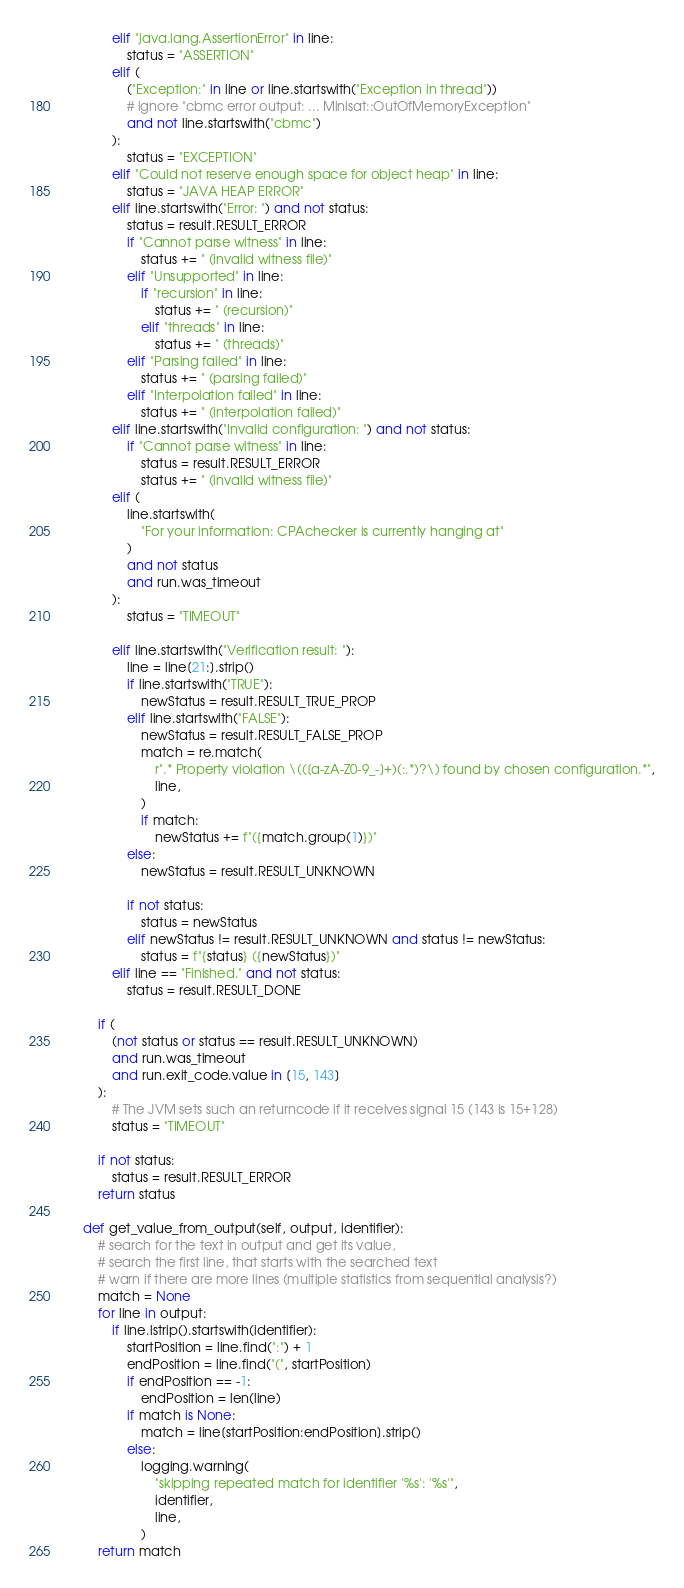<code> <loc_0><loc_0><loc_500><loc_500><_Python_>            elif "java.lang.AssertionError" in line:
                status = "ASSERTION"
            elif (
                ("Exception:" in line or line.startswith("Exception in thread"))
                # ignore "cbmc error output: ... Minisat::OutOfMemoryException"
                and not line.startswith("cbmc")
            ):
                status = "EXCEPTION"
            elif "Could not reserve enough space for object heap" in line:
                status = "JAVA HEAP ERROR"
            elif line.startswith("Error: ") and not status:
                status = result.RESULT_ERROR
                if "Cannot parse witness" in line:
                    status += " (invalid witness file)"
                elif "Unsupported" in line:
                    if "recursion" in line:
                        status += " (recursion)"
                    elif "threads" in line:
                        status += " (threads)"
                elif "Parsing failed" in line:
                    status += " (parsing failed)"
                elif "Interpolation failed" in line:
                    status += " (interpolation failed)"
            elif line.startswith("Invalid configuration: ") and not status:
                if "Cannot parse witness" in line:
                    status = result.RESULT_ERROR
                    status += " (invalid witness file)"
            elif (
                line.startswith(
                    "For your information: CPAchecker is currently hanging at"
                )
                and not status
                and run.was_timeout
            ):
                status = "TIMEOUT"

            elif line.startswith("Verification result: "):
                line = line[21:].strip()
                if line.startswith("TRUE"):
                    newStatus = result.RESULT_TRUE_PROP
                elif line.startswith("FALSE"):
                    newStatus = result.RESULT_FALSE_PROP
                    match = re.match(
                        r".* Property violation \(([a-zA-Z0-9_-]+)(:.*)?\) found by chosen configuration.*",
                        line,
                    )
                    if match:
                        newStatus += f"({match.group(1)})"
                else:
                    newStatus = result.RESULT_UNKNOWN

                if not status:
                    status = newStatus
                elif newStatus != result.RESULT_UNKNOWN and status != newStatus:
                    status = f"{status} ({newStatus})"
            elif line == "Finished." and not status:
                status = result.RESULT_DONE

        if (
            (not status or status == result.RESULT_UNKNOWN)
            and run.was_timeout
            and run.exit_code.value in [15, 143]
        ):
            # The JVM sets such an returncode if it receives signal 15 (143 is 15+128)
            status = "TIMEOUT"

        if not status:
            status = result.RESULT_ERROR
        return status

    def get_value_from_output(self, output, identifier):
        # search for the text in output and get its value,
        # search the first line, that starts with the searched text
        # warn if there are more lines (multiple statistics from sequential analysis?)
        match = None
        for line in output:
            if line.lstrip().startswith(identifier):
                startPosition = line.find(":") + 1
                endPosition = line.find("(", startPosition)
                if endPosition == -1:
                    endPosition = len(line)
                if match is None:
                    match = line[startPosition:endPosition].strip()
                else:
                    logging.warning(
                        "skipping repeated match for identifier '%s': '%s'",
                        identifier,
                        line,
                    )
        return match
</code> 